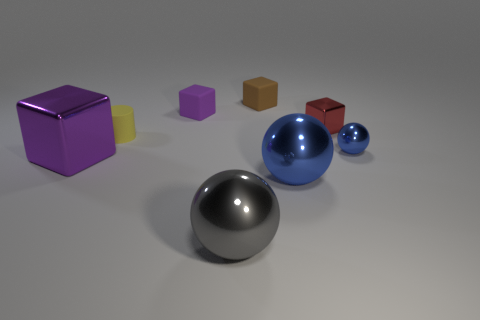There is a rubber block in front of the small brown matte cube; is its color the same as the large metal cube?
Give a very brief answer. Yes. Are the blue ball that is in front of the small blue shiny ball and the sphere that is in front of the large blue shiny ball made of the same material?
Keep it short and to the point. Yes. How many other cylinders have the same color as the small cylinder?
Your response must be concise. 0. There is a large metal object that is to the right of the tiny purple matte thing and behind the gray shiny thing; what is its shape?
Your response must be concise. Sphere. The shiny sphere that is right of the tiny brown thing and left of the tiny blue metallic sphere is what color?
Give a very brief answer. Blue. Is the number of cubes that are in front of the tiny purple block greater than the number of yellow cylinders on the left side of the brown matte thing?
Your answer should be compact. Yes. What color is the metal cube that is behind the big metal block?
Make the answer very short. Red. There is a blue object that is behind the purple shiny object; does it have the same shape as the small metallic thing behind the tiny ball?
Ensure brevity in your answer.  No. Are there any blue spheres of the same size as the rubber cylinder?
Offer a terse response. Yes. What is the material of the small yellow thing in front of the tiny metallic cube?
Your response must be concise. Rubber. 